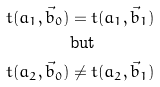<formula> <loc_0><loc_0><loc_500><loc_500>t ( a _ { 1 } , \vec { b } _ { 0 } ) & = t ( a _ { 1 } , \vec { b } _ { 1 } ) \\ & \text {but} \\ t ( a _ { 2 } , \vec { b } _ { 0 } ) & \neq t ( a _ { 2 } , \vec { b } _ { 1 } )</formula> 